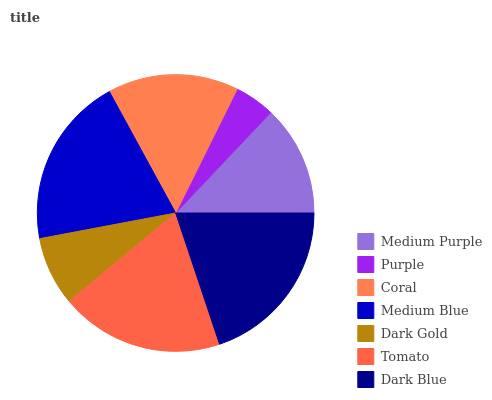Is Purple the minimum?
Answer yes or no. Yes. Is Medium Blue the maximum?
Answer yes or no. Yes. Is Coral the minimum?
Answer yes or no. No. Is Coral the maximum?
Answer yes or no. No. Is Coral greater than Purple?
Answer yes or no. Yes. Is Purple less than Coral?
Answer yes or no. Yes. Is Purple greater than Coral?
Answer yes or no. No. Is Coral less than Purple?
Answer yes or no. No. Is Coral the high median?
Answer yes or no. Yes. Is Coral the low median?
Answer yes or no. Yes. Is Medium Purple the high median?
Answer yes or no. No. Is Medium Purple the low median?
Answer yes or no. No. 